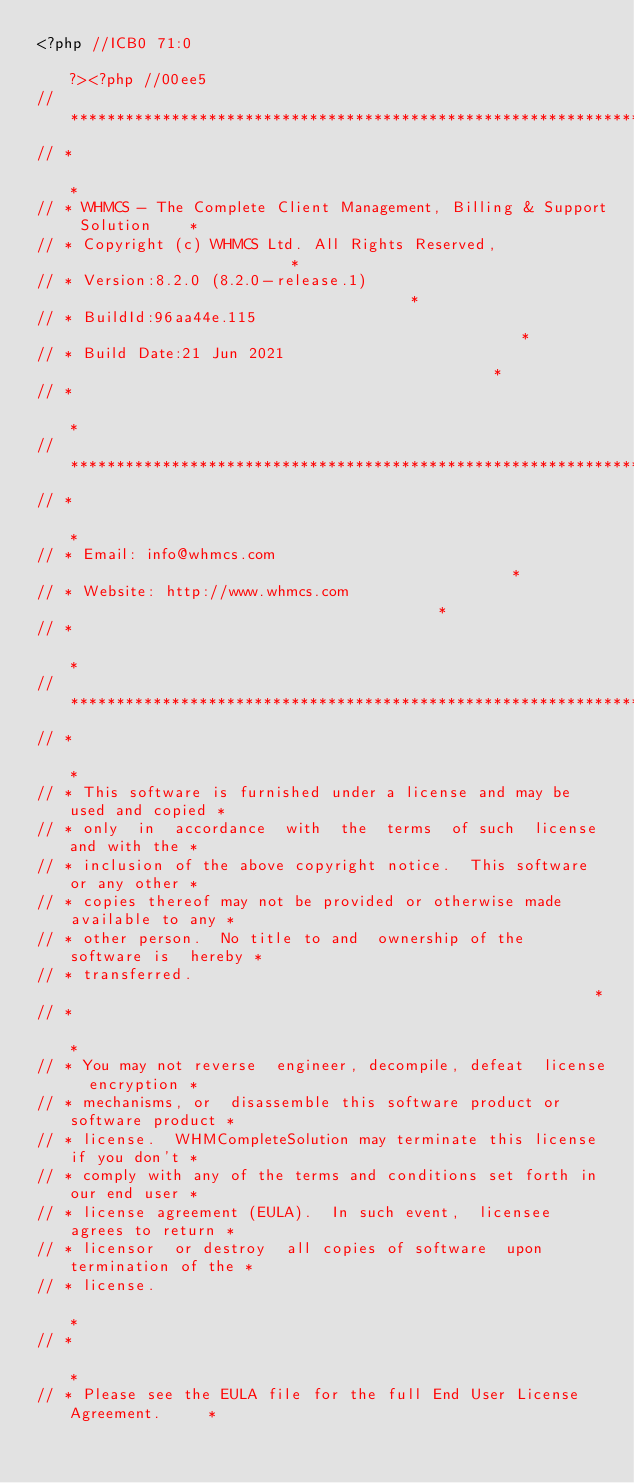<code> <loc_0><loc_0><loc_500><loc_500><_PHP_><?php //ICB0 71:0                                                             ?><?php //00ee5
// *************************************************************************
// *                                                                       *
// * WHMCS - The Complete Client Management, Billing & Support Solution    *
// * Copyright (c) WHMCS Ltd. All Rights Reserved,                         *
// * Version:8.2.0 (8.2.0-release.1)                                      *
// * BuildId:96aa44e.115                                                  *
// * Build Date:21 Jun 2021                                               *
// *                                                                       *
// *************************************************************************
// *                                                                       *
// * Email: info@whmcs.com                                                 *
// * Website: http://www.whmcs.com                                         *
// *                                                                       *
// *************************************************************************
// *                                                                       *
// * This software is furnished under a license and may be used and copied *
// * only  in  accordance  with  the  terms  of such  license and with the *
// * inclusion of the above copyright notice.  This software  or any other *
// * copies thereof may not be provided or otherwise made available to any *
// * other person.  No title to and  ownership of the  software is  hereby *
// * transferred.                                                          *
// *                                                                       *
// * You may not reverse  engineer, decompile, defeat  license  encryption *
// * mechanisms, or  disassemble this software product or software product *
// * license.  WHMCompleteSolution may terminate this license if you don't *
// * comply with any of the terms and conditions set forth in our end user *
// * license agreement (EULA).  In such event,  licensee  agrees to return *
// * licensor  or destroy  all copies of software  upon termination of the *
// * license.                                                              *
// *                                                                       *
// * Please see the EULA file for the full End User License Agreement.     *</code> 